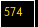<code> <loc_0><loc_0><loc_500><loc_500><_C_>
</code> 